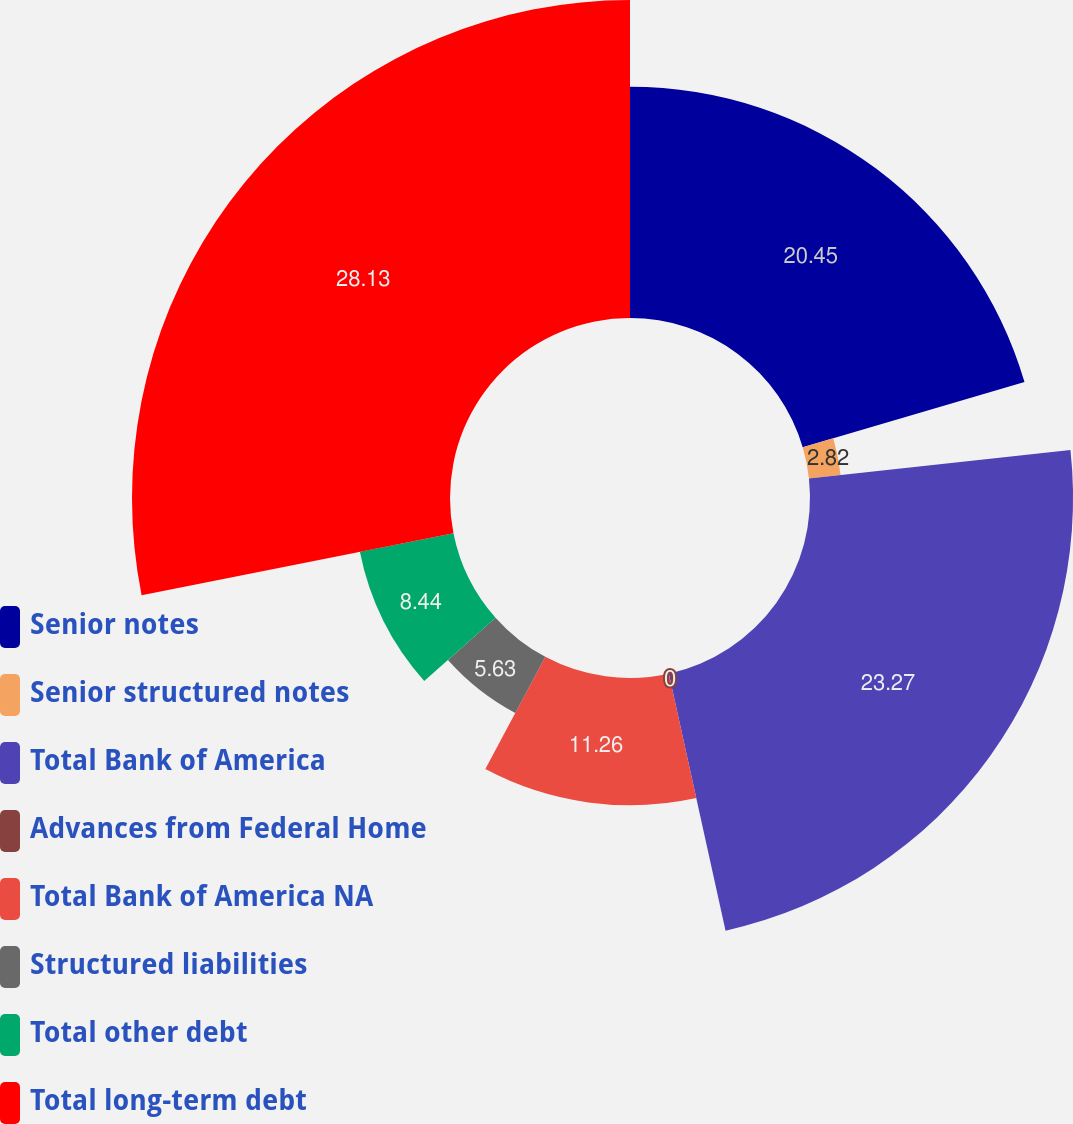Convert chart to OTSL. <chart><loc_0><loc_0><loc_500><loc_500><pie_chart><fcel>Senior notes<fcel>Senior structured notes<fcel>Total Bank of America<fcel>Advances from Federal Home<fcel>Total Bank of America NA<fcel>Structured liabilities<fcel>Total other debt<fcel>Total long-term debt<nl><fcel>20.45%<fcel>2.82%<fcel>23.27%<fcel>0.0%<fcel>11.26%<fcel>5.63%<fcel>8.44%<fcel>28.13%<nl></chart> 